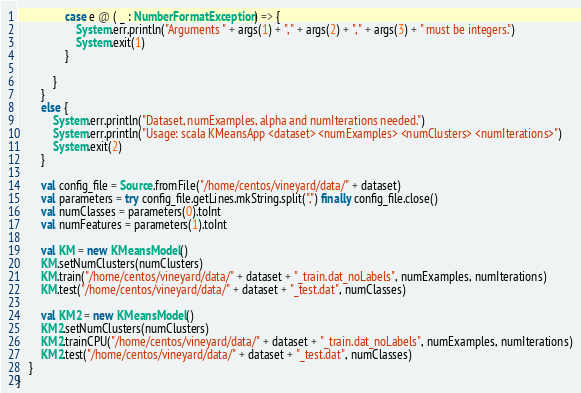Convert code to text. <code><loc_0><loc_0><loc_500><loc_500><_Scala_>				case e @ ( _ : NumberFormatException) => {
					System.err.println("Arguments " + args(1) + ", " + args(2) + ", " + args(3) + " must be integers.")
					System.exit(1)
				}

			}
		}
		else {
			System.err.println("Dataset, numExamples, alpha and numIterations needed.")
			System.err.println("Usage: scala KMeansApp <dataset> <numExamples> <numClusters> <numIterations>")
			System.exit(2)
		}

		val config_file = Source.fromFile("/home/centos/vineyard/data/" + dataset)
		val parameters = try config_file.getLines.mkString.split(",") finally config_file.close()
		val numClasses = parameters(0).toInt
		val numFeatures = parameters(1).toInt

		val KM = new KMeansModel()
		KM.setNumClusters(numClusters)
		KM.train("/home/centos/vineyard/data/" + dataset + "_train.dat_noLabels", numExamples, numIterations)
		KM.test("/home/centos/vineyard/data/" + dataset + "_test.dat", numClasses)

		val KM2 = new KMeansModel()
		KM2.setNumClusters(numClusters)
		KM2.trainCPU("/home/centos/vineyard/data/" + dataset + "_train.dat_noLabels", numExamples, numIterations)
		KM2.test("/home/centos/vineyard/data/" + dataset + "_test.dat", numClasses)
	}
}
</code> 